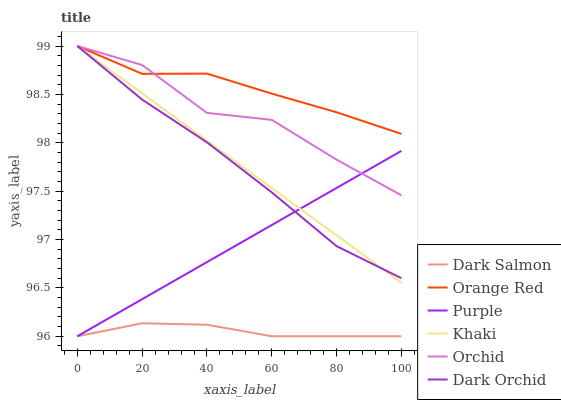Does Dark Salmon have the minimum area under the curve?
Answer yes or no. Yes. Does Orange Red have the maximum area under the curve?
Answer yes or no. Yes. Does Purple have the minimum area under the curve?
Answer yes or no. No. Does Purple have the maximum area under the curve?
Answer yes or no. No. Is Khaki the smoothest?
Answer yes or no. Yes. Is Orchid the roughest?
Answer yes or no. Yes. Is Purple the smoothest?
Answer yes or no. No. Is Purple the roughest?
Answer yes or no. No. Does Purple have the lowest value?
Answer yes or no. Yes. Does Dark Orchid have the lowest value?
Answer yes or no. No. Does Orchid have the highest value?
Answer yes or no. Yes. Does Purple have the highest value?
Answer yes or no. No. Is Dark Salmon less than Dark Orchid?
Answer yes or no. Yes. Is Khaki greater than Dark Salmon?
Answer yes or no. Yes. Does Khaki intersect Purple?
Answer yes or no. Yes. Is Khaki less than Purple?
Answer yes or no. No. Is Khaki greater than Purple?
Answer yes or no. No. Does Dark Salmon intersect Dark Orchid?
Answer yes or no. No. 